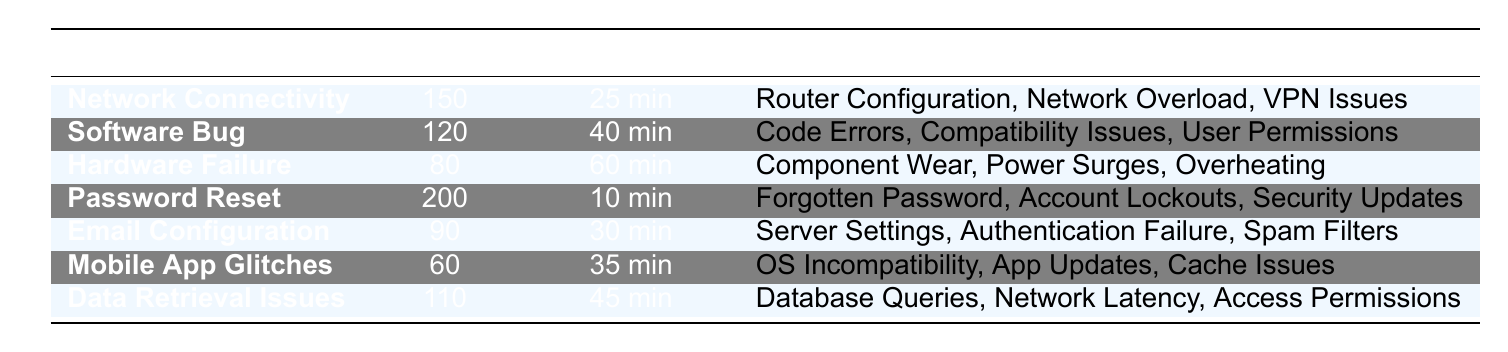What is the issue type with the highest resolved count? Looking at the table, we can see that the issue type with the highest resolved count is "Password Reset," which has a resolved count of 200.
Answer: Password Reset What is the average duration for resolving a Hardware Failure? The table shows that the average duration for resolving a Hardware Failure is 60 minutes.
Answer: 60 minutes How many issues were resolved for Network Connectivity and Software Bug combined? By adding the resolved counts for both Network Connectivity (150) and Software Bug (120), we get a total of 150 + 120 = 270.
Answer: 270 Is the average duration for resolving Mobile App Glitches shorter than that for Email Configuration? The average duration for Mobile App Glitches is 35 minutes, while for Email Configuration, it is 30 minutes. Since 35 minutes is not shorter than 30 minutes, the statement is false.
Answer: No What is the average resolution time for the three issue types with the highest resolved counts? The three issue types with the highest resolved counts are Password Reset (200), Network Connectivity (150), and Software Bug (120). Their average resolution time is (10 + 25 + 40) / 3 = 25 minutes.
Answer: 25 minutes What common cause is shared between Data Retrieval Issues and Email Configuration? The common cause listed for both Data Retrieval Issues and Email Configuration is "Network Latency" and "Server Settings," respectively, but since there’s no overlap on causes provided in the data, there is no shared common cause.
Answer: None Which issue type has the largest average duration? The table indicates that Hardware Failure has the largest average duration at 60 minutes when compared to all other issue types.
Answer: Hardware Failure What percentage of total resolved issues does the Password Reset account for? To find this percentage, we first total all resolved counts: 150 + 120 + 80 + 200 + 90 + 60 + 110 = 910. Next, we calculate the percentage for Password Reset: (200 / 910) * 100 ≈ 21.98%.
Answer: Approximately 22% 